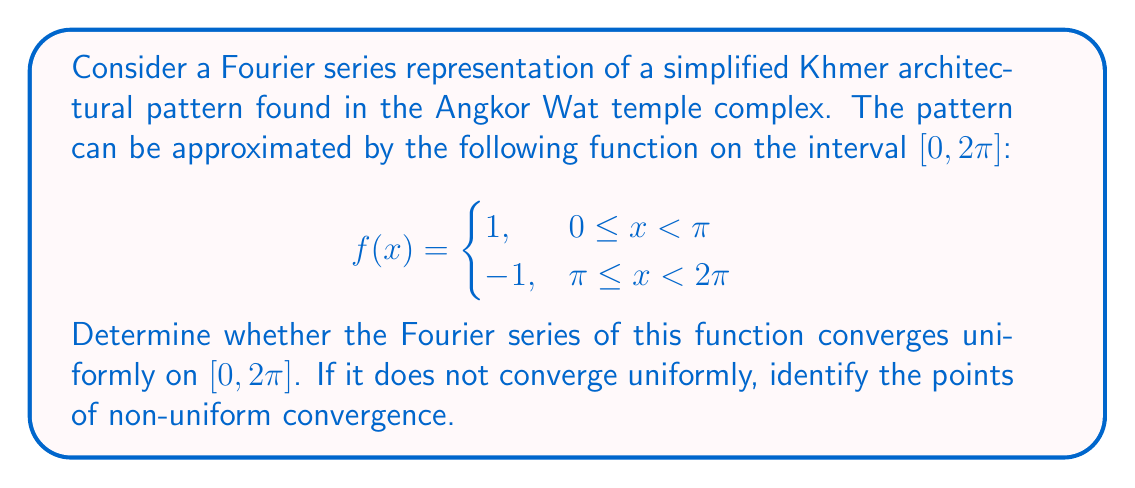Teach me how to tackle this problem. To analyze the convergence of the Fourier series, we'll follow these steps:

1) First, let's recall the Fourier series for an odd function:

   $$f(x) = \sum_{n=1}^{\infty} b_n \sin(nx)$$

   where $b_n = \frac{2}{\pi} \int_0^\pi f(x) \sin(nx) dx$

2) For our function, we can calculate $b_n$:

   $$b_n = \frac{2}{\pi} \int_0^\pi \sin(nx) dx = \frac{4}{n\pi} \text{ for odd } n, \text{ and } 0 \text{ for even } n$$

3) Thus, our Fourier series is:

   $$S(x) = \frac{4}{\pi} \sum_{k=0}^{\infty} \frac{\sin((2k+1)x)}{2k+1}$$

4) To check for uniform convergence, we need to examine the behavior of the partial sums:

   $$S_N(x) = \frac{4}{\pi} \sum_{k=0}^{N} \frac{\sin((2k+1)x)}{2k+1}$$

5) The difference between $f(x)$ and $S_N(x)$ is given by:

   $$f(x) - S_N(x) = \frac{4}{\pi} \sum_{k=N+1}^{\infty} \frac{\sin((2k+1)x)}{2k+1}$$

6) For uniform convergence, we need $\sup_{x \in [0,2\pi]} |f(x) - S_N(x)| \to 0$ as $N \to \infty$.

7) However, at the points of discontinuity ($x = 0, \pi, 2\pi$), the partial sums exhibit the Gibbs phenomenon. The overshoot doesn't vanish as $N \to \infty$.

8) Specifically, at these points:

   $$\lim_{N \to \infty} S_N(0^+) = \lim_{N \to \infty} S_N(2\pi^-) \approx 1.18$$
   $$\lim_{N \to \infty} S_N(\pi^-) \approx 1.18$$
   $$\lim_{N \to \infty} S_N(\pi^+) \approx -1.18$$

9) This overshoot of approximately 18% persists no matter how many terms we take in the series.

Therefore, the Fourier series does not converge uniformly on $[0, 2\pi]$. The points of non-uniform convergence are $x = 0, \pi, \text{ and } 2\pi$, which correspond to the discontinuities in the original function.
Answer: The Fourier series does not converge uniformly on $[0, 2\pi]$. The points of non-uniform convergence are $x = 0, \pi, \text{ and } 2\pi$. 